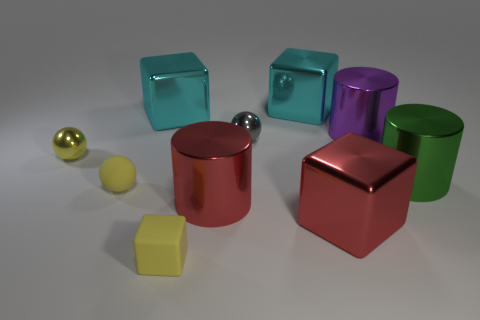Is there a yellow thing that is in front of the big shiny block in front of the big cylinder behind the small gray ball?
Ensure brevity in your answer.  Yes. There is a big green shiny cylinder; are there any large objects on the right side of it?
Provide a short and direct response. No. What number of big metallic cubes have the same color as the matte ball?
Make the answer very short. 0. What is the size of the purple object that is the same material as the gray sphere?
Keep it short and to the point. Large. How big is the red thing left of the cyan metallic block that is on the right side of the cyan object that is on the left side of the big red cylinder?
Your answer should be compact. Large. There is a metallic cylinder that is to the right of the big purple metal cylinder; what is its size?
Offer a terse response. Large. What number of red objects are large objects or tiny blocks?
Offer a very short reply. 2. Is there a red metal cylinder of the same size as the rubber ball?
Your answer should be compact. No. There is a block that is the same size as the gray shiny sphere; what is its material?
Provide a succinct answer. Rubber. Does the purple cylinder that is on the left side of the green object have the same size as the red shiny thing that is to the right of the tiny gray thing?
Provide a succinct answer. Yes. 